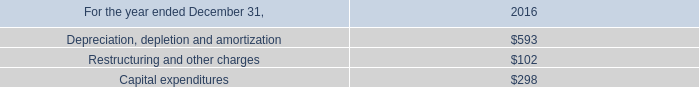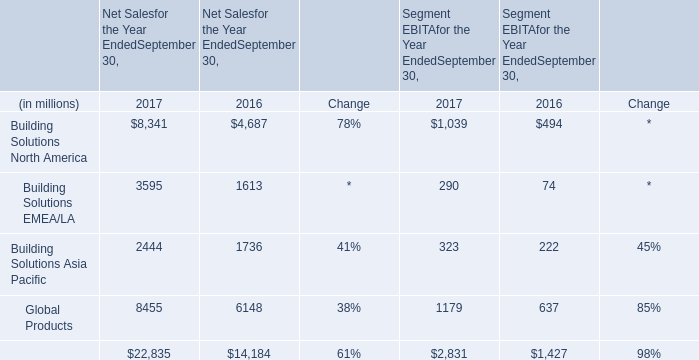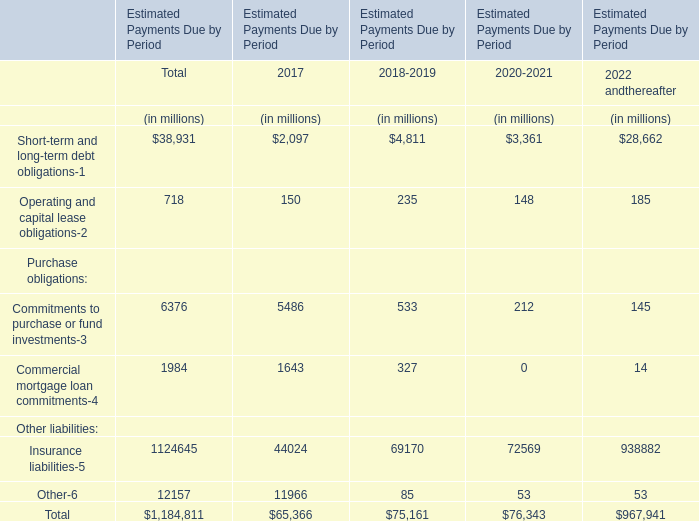What's the Estimated Payments Due by Period 2018-2019 in terms of Other liabilities ? (in million) 
Computations: (69170 + 85)
Answer: 69255.0. 